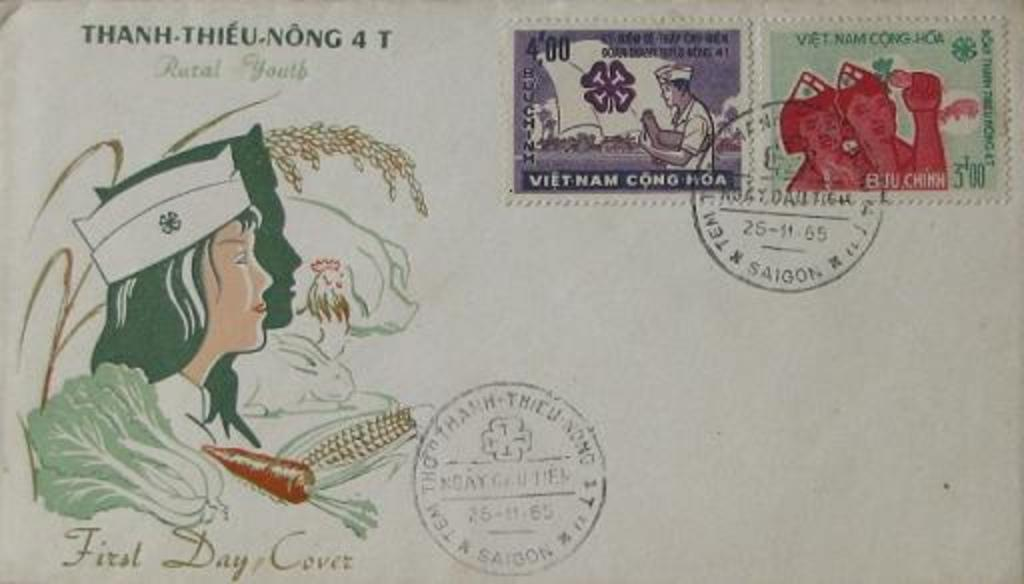<image>
Write a terse but informative summary of the picture. an envelope from Thanh Thieu Nong with Vietnamese stamps 